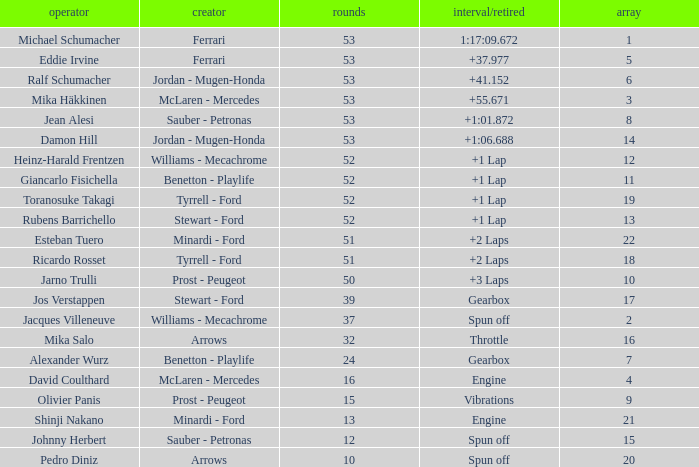What is the grid total for ralf schumacher racing over 53 laps? None. 